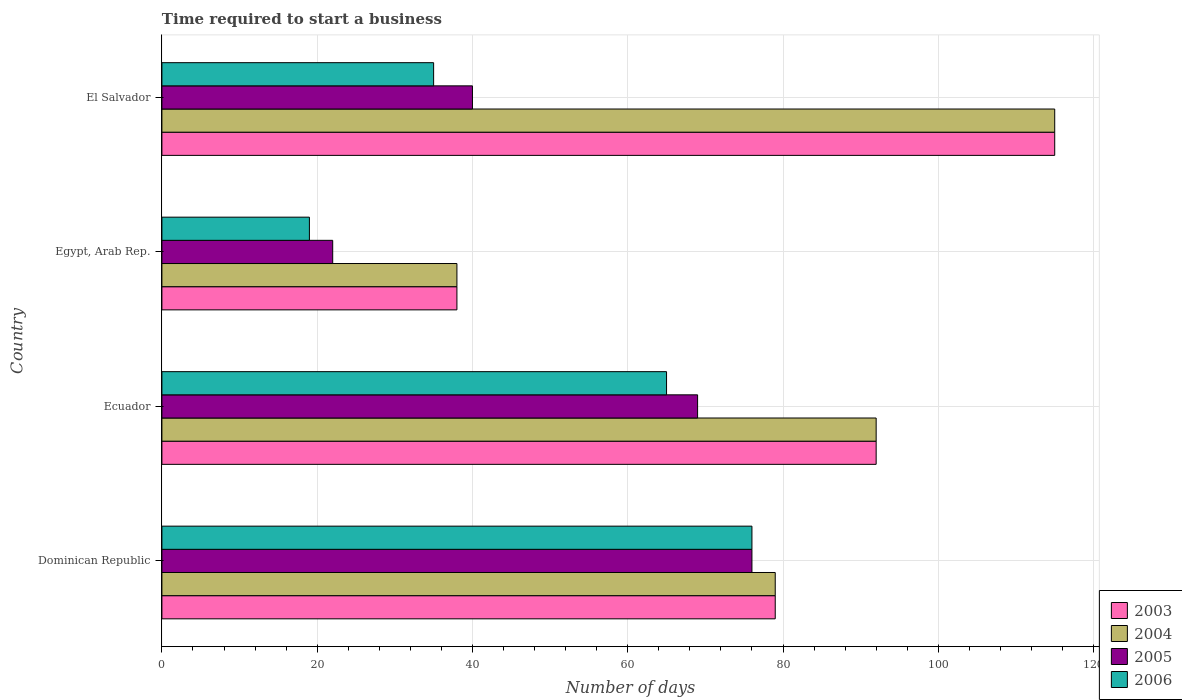How many different coloured bars are there?
Your answer should be very brief. 4. How many groups of bars are there?
Provide a short and direct response. 4. Are the number of bars per tick equal to the number of legend labels?
Give a very brief answer. Yes. Are the number of bars on each tick of the Y-axis equal?
Keep it short and to the point. Yes. What is the label of the 3rd group of bars from the top?
Offer a very short reply. Ecuador. In how many cases, is the number of bars for a given country not equal to the number of legend labels?
Your response must be concise. 0. What is the number of days required to start a business in 2003 in Dominican Republic?
Your response must be concise. 79. In which country was the number of days required to start a business in 2004 maximum?
Give a very brief answer. El Salvador. In which country was the number of days required to start a business in 2006 minimum?
Offer a terse response. Egypt, Arab Rep. What is the total number of days required to start a business in 2004 in the graph?
Give a very brief answer. 324. What is the difference between the number of days required to start a business in 2006 in Dominican Republic and that in Ecuador?
Give a very brief answer. 11. What is the difference between the number of days required to start a business in 2006 in El Salvador and the number of days required to start a business in 2005 in Ecuador?
Make the answer very short. -34. What is the average number of days required to start a business in 2005 per country?
Make the answer very short. 51.75. What is the ratio of the number of days required to start a business in 2006 in Egypt, Arab Rep. to that in El Salvador?
Offer a very short reply. 0.54. Is the number of days required to start a business in 2005 in Dominican Republic less than that in Egypt, Arab Rep.?
Offer a very short reply. No. What is the difference between the highest and the second highest number of days required to start a business in 2006?
Provide a short and direct response. 11. What is the difference between the highest and the lowest number of days required to start a business in 2005?
Offer a terse response. 54. In how many countries, is the number of days required to start a business in 2003 greater than the average number of days required to start a business in 2003 taken over all countries?
Your response must be concise. 2. Is the sum of the number of days required to start a business in 2004 in Dominican Republic and El Salvador greater than the maximum number of days required to start a business in 2006 across all countries?
Your response must be concise. Yes. What does the 1st bar from the top in El Salvador represents?
Your answer should be very brief. 2006. Is it the case that in every country, the sum of the number of days required to start a business in 2006 and number of days required to start a business in 2005 is greater than the number of days required to start a business in 2003?
Your answer should be compact. No. How many bars are there?
Ensure brevity in your answer.  16. Are all the bars in the graph horizontal?
Ensure brevity in your answer.  Yes. Does the graph contain any zero values?
Offer a terse response. No. Where does the legend appear in the graph?
Give a very brief answer. Bottom right. How many legend labels are there?
Ensure brevity in your answer.  4. What is the title of the graph?
Give a very brief answer. Time required to start a business. What is the label or title of the X-axis?
Offer a terse response. Number of days. What is the label or title of the Y-axis?
Offer a terse response. Country. What is the Number of days of 2003 in Dominican Republic?
Your response must be concise. 79. What is the Number of days of 2004 in Dominican Republic?
Your response must be concise. 79. What is the Number of days of 2003 in Ecuador?
Keep it short and to the point. 92. What is the Number of days of 2004 in Ecuador?
Offer a terse response. 92. What is the Number of days of 2005 in Ecuador?
Provide a succinct answer. 69. What is the Number of days in 2006 in Ecuador?
Ensure brevity in your answer.  65. What is the Number of days in 2003 in Egypt, Arab Rep.?
Your answer should be compact. 38. What is the Number of days of 2004 in Egypt, Arab Rep.?
Give a very brief answer. 38. What is the Number of days in 2003 in El Salvador?
Make the answer very short. 115. What is the Number of days in 2004 in El Salvador?
Keep it short and to the point. 115. Across all countries, what is the maximum Number of days of 2003?
Provide a short and direct response. 115. Across all countries, what is the maximum Number of days of 2004?
Provide a succinct answer. 115. Across all countries, what is the maximum Number of days in 2005?
Offer a terse response. 76. Across all countries, what is the minimum Number of days in 2004?
Offer a terse response. 38. What is the total Number of days of 2003 in the graph?
Your response must be concise. 324. What is the total Number of days of 2004 in the graph?
Your answer should be very brief. 324. What is the total Number of days of 2005 in the graph?
Ensure brevity in your answer.  207. What is the total Number of days in 2006 in the graph?
Offer a terse response. 195. What is the difference between the Number of days in 2003 in Dominican Republic and that in Ecuador?
Give a very brief answer. -13. What is the difference between the Number of days of 2004 in Dominican Republic and that in Ecuador?
Ensure brevity in your answer.  -13. What is the difference between the Number of days in 2005 in Dominican Republic and that in Ecuador?
Make the answer very short. 7. What is the difference between the Number of days of 2003 in Dominican Republic and that in Egypt, Arab Rep.?
Your answer should be compact. 41. What is the difference between the Number of days in 2006 in Dominican Republic and that in Egypt, Arab Rep.?
Keep it short and to the point. 57. What is the difference between the Number of days of 2003 in Dominican Republic and that in El Salvador?
Your answer should be compact. -36. What is the difference between the Number of days of 2004 in Dominican Republic and that in El Salvador?
Your answer should be very brief. -36. What is the difference between the Number of days of 2006 in Dominican Republic and that in El Salvador?
Give a very brief answer. 41. What is the difference between the Number of days of 2005 in Ecuador and that in Egypt, Arab Rep.?
Give a very brief answer. 47. What is the difference between the Number of days in 2003 in Ecuador and that in El Salvador?
Your answer should be very brief. -23. What is the difference between the Number of days of 2006 in Ecuador and that in El Salvador?
Ensure brevity in your answer.  30. What is the difference between the Number of days in 2003 in Egypt, Arab Rep. and that in El Salvador?
Provide a succinct answer. -77. What is the difference between the Number of days of 2004 in Egypt, Arab Rep. and that in El Salvador?
Provide a short and direct response. -77. What is the difference between the Number of days in 2006 in Egypt, Arab Rep. and that in El Salvador?
Ensure brevity in your answer.  -16. What is the difference between the Number of days in 2003 in Dominican Republic and the Number of days in 2006 in Ecuador?
Your response must be concise. 14. What is the difference between the Number of days in 2004 in Dominican Republic and the Number of days in 2006 in Ecuador?
Give a very brief answer. 14. What is the difference between the Number of days of 2003 in Dominican Republic and the Number of days of 2005 in Egypt, Arab Rep.?
Make the answer very short. 57. What is the difference between the Number of days in 2003 in Dominican Republic and the Number of days in 2004 in El Salvador?
Your answer should be compact. -36. What is the difference between the Number of days of 2003 in Dominican Republic and the Number of days of 2006 in El Salvador?
Give a very brief answer. 44. What is the difference between the Number of days of 2004 in Dominican Republic and the Number of days of 2005 in El Salvador?
Make the answer very short. 39. What is the difference between the Number of days of 2004 in Dominican Republic and the Number of days of 2006 in El Salvador?
Offer a very short reply. 44. What is the difference between the Number of days in 2003 in Ecuador and the Number of days in 2004 in Egypt, Arab Rep.?
Ensure brevity in your answer.  54. What is the difference between the Number of days of 2003 in Ecuador and the Number of days of 2005 in Egypt, Arab Rep.?
Provide a short and direct response. 70. What is the difference between the Number of days of 2003 in Ecuador and the Number of days of 2006 in Egypt, Arab Rep.?
Make the answer very short. 73. What is the difference between the Number of days of 2003 in Ecuador and the Number of days of 2004 in El Salvador?
Your answer should be very brief. -23. What is the difference between the Number of days of 2003 in Ecuador and the Number of days of 2006 in El Salvador?
Your answer should be compact. 57. What is the difference between the Number of days of 2004 in Ecuador and the Number of days of 2005 in El Salvador?
Offer a terse response. 52. What is the difference between the Number of days in 2005 in Ecuador and the Number of days in 2006 in El Salvador?
Make the answer very short. 34. What is the difference between the Number of days in 2003 in Egypt, Arab Rep. and the Number of days in 2004 in El Salvador?
Your response must be concise. -77. What is the difference between the Number of days in 2003 in Egypt, Arab Rep. and the Number of days in 2005 in El Salvador?
Make the answer very short. -2. What is the difference between the Number of days in 2003 in Egypt, Arab Rep. and the Number of days in 2006 in El Salvador?
Offer a terse response. 3. What is the difference between the Number of days in 2004 in Egypt, Arab Rep. and the Number of days in 2006 in El Salvador?
Your answer should be compact. 3. What is the average Number of days of 2003 per country?
Provide a succinct answer. 81. What is the average Number of days in 2005 per country?
Your answer should be very brief. 51.75. What is the average Number of days in 2006 per country?
Provide a short and direct response. 48.75. What is the difference between the Number of days in 2003 and Number of days in 2004 in Dominican Republic?
Your answer should be compact. 0. What is the difference between the Number of days of 2004 and Number of days of 2005 in Dominican Republic?
Offer a very short reply. 3. What is the difference between the Number of days of 2004 and Number of days of 2006 in Dominican Republic?
Make the answer very short. 3. What is the difference between the Number of days in 2005 and Number of days in 2006 in Dominican Republic?
Ensure brevity in your answer.  0. What is the difference between the Number of days in 2003 and Number of days in 2004 in Ecuador?
Make the answer very short. 0. What is the difference between the Number of days of 2004 and Number of days of 2005 in Ecuador?
Make the answer very short. 23. What is the difference between the Number of days of 2005 and Number of days of 2006 in Ecuador?
Make the answer very short. 4. What is the difference between the Number of days of 2003 and Number of days of 2004 in Egypt, Arab Rep.?
Give a very brief answer. 0. What is the difference between the Number of days of 2003 and Number of days of 2005 in Egypt, Arab Rep.?
Offer a terse response. 16. What is the difference between the Number of days in 2004 and Number of days in 2006 in Egypt, Arab Rep.?
Make the answer very short. 19. What is the difference between the Number of days of 2003 and Number of days of 2004 in El Salvador?
Make the answer very short. 0. What is the difference between the Number of days in 2003 and Number of days in 2006 in El Salvador?
Your answer should be very brief. 80. What is the ratio of the Number of days of 2003 in Dominican Republic to that in Ecuador?
Provide a short and direct response. 0.86. What is the ratio of the Number of days of 2004 in Dominican Republic to that in Ecuador?
Your response must be concise. 0.86. What is the ratio of the Number of days of 2005 in Dominican Republic to that in Ecuador?
Your answer should be compact. 1.1. What is the ratio of the Number of days of 2006 in Dominican Republic to that in Ecuador?
Ensure brevity in your answer.  1.17. What is the ratio of the Number of days of 2003 in Dominican Republic to that in Egypt, Arab Rep.?
Make the answer very short. 2.08. What is the ratio of the Number of days in 2004 in Dominican Republic to that in Egypt, Arab Rep.?
Your answer should be very brief. 2.08. What is the ratio of the Number of days of 2005 in Dominican Republic to that in Egypt, Arab Rep.?
Offer a very short reply. 3.45. What is the ratio of the Number of days in 2003 in Dominican Republic to that in El Salvador?
Your answer should be very brief. 0.69. What is the ratio of the Number of days of 2004 in Dominican Republic to that in El Salvador?
Ensure brevity in your answer.  0.69. What is the ratio of the Number of days of 2005 in Dominican Republic to that in El Salvador?
Your answer should be very brief. 1.9. What is the ratio of the Number of days in 2006 in Dominican Republic to that in El Salvador?
Your answer should be very brief. 2.17. What is the ratio of the Number of days in 2003 in Ecuador to that in Egypt, Arab Rep.?
Keep it short and to the point. 2.42. What is the ratio of the Number of days in 2004 in Ecuador to that in Egypt, Arab Rep.?
Ensure brevity in your answer.  2.42. What is the ratio of the Number of days of 2005 in Ecuador to that in Egypt, Arab Rep.?
Give a very brief answer. 3.14. What is the ratio of the Number of days of 2006 in Ecuador to that in Egypt, Arab Rep.?
Provide a succinct answer. 3.42. What is the ratio of the Number of days in 2004 in Ecuador to that in El Salvador?
Make the answer very short. 0.8. What is the ratio of the Number of days in 2005 in Ecuador to that in El Salvador?
Give a very brief answer. 1.73. What is the ratio of the Number of days in 2006 in Ecuador to that in El Salvador?
Make the answer very short. 1.86. What is the ratio of the Number of days in 2003 in Egypt, Arab Rep. to that in El Salvador?
Make the answer very short. 0.33. What is the ratio of the Number of days of 2004 in Egypt, Arab Rep. to that in El Salvador?
Make the answer very short. 0.33. What is the ratio of the Number of days of 2005 in Egypt, Arab Rep. to that in El Salvador?
Make the answer very short. 0.55. What is the ratio of the Number of days of 2006 in Egypt, Arab Rep. to that in El Salvador?
Make the answer very short. 0.54. What is the difference between the highest and the second highest Number of days in 2003?
Give a very brief answer. 23. What is the difference between the highest and the second highest Number of days of 2004?
Keep it short and to the point. 23. What is the difference between the highest and the lowest Number of days of 2003?
Offer a very short reply. 77. 